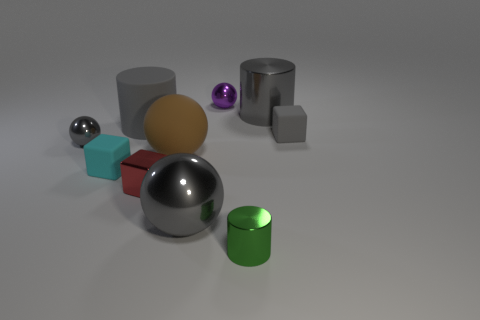How many gray cylinders have the same material as the green cylinder?
Your answer should be very brief. 1. The other tiny block that is the same material as the cyan block is what color?
Your response must be concise. Gray. What is the size of the gray cylinder that is to the left of the gray ball that is right of the metallic sphere on the left side of the small red metal cube?
Your answer should be compact. Large. Is the number of big cyan rubber spheres less than the number of large gray metallic cylinders?
Offer a very short reply. Yes. What is the color of the other large metallic thing that is the same shape as the green metal thing?
Give a very brief answer. Gray. There is a big metal thing that is to the left of the large object that is to the right of the tiny green shiny thing; is there a gray rubber object to the left of it?
Offer a very short reply. Yes. Does the red thing have the same shape as the tiny green object?
Offer a terse response. No. Is the number of tiny gray shiny balls in front of the cyan matte cube less than the number of large brown matte blocks?
Ensure brevity in your answer.  No. There is a tiny rubber cube that is on the left side of the tiny metallic sphere on the right side of the tiny matte thing in front of the small gray metallic thing; what is its color?
Your answer should be compact. Cyan. What number of metallic objects are big cyan spheres or purple objects?
Your answer should be very brief. 1. 